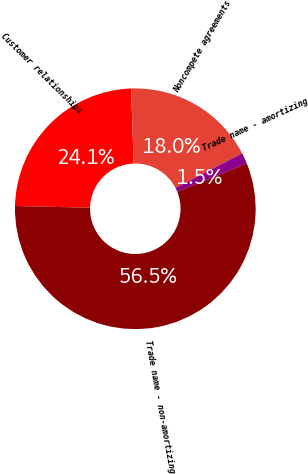<chart> <loc_0><loc_0><loc_500><loc_500><pie_chart><fcel>Customer relationships<fcel>Noncompete agreements<fcel>Trade name - amortizing<fcel>Trade name - non-amortizing<nl><fcel>24.08%<fcel>17.95%<fcel>1.47%<fcel>56.5%<nl></chart> 